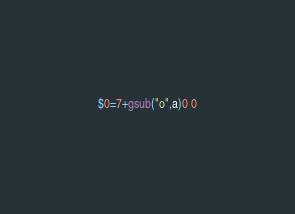<code> <loc_0><loc_0><loc_500><loc_500><_Awk_>$0=7+gsub("o",a)0 0</code> 